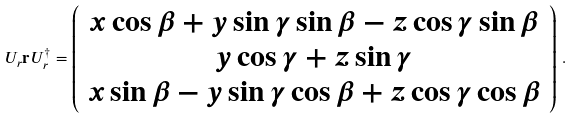<formula> <loc_0><loc_0><loc_500><loc_500>U _ { r } \mathbf r U _ { r } ^ { \dagger } = \left ( \begin{array} { c } x \cos \beta + y \sin \gamma \sin \beta - z \cos \gamma \sin \beta \\ y \cos \gamma + z \sin \gamma \\ x \sin \beta - y \sin \gamma \cos \beta + z \cos \gamma \cos \beta \end{array} \right ) \, .</formula> 